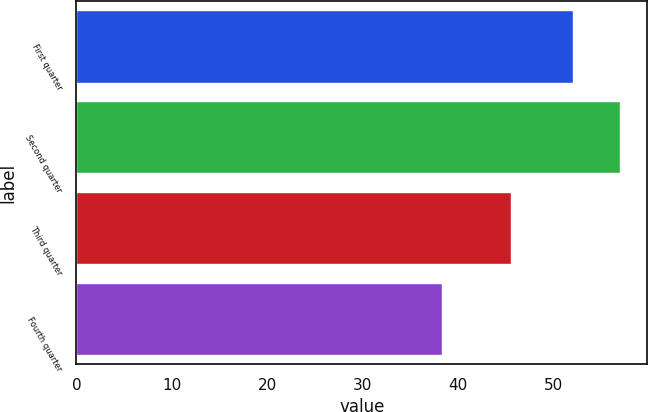Convert chart. <chart><loc_0><loc_0><loc_500><loc_500><bar_chart><fcel>First quarter<fcel>Second quarter<fcel>Third quarter<fcel>Fourth quarter<nl><fcel>52.06<fcel>57<fcel>45.54<fcel>38.34<nl></chart> 